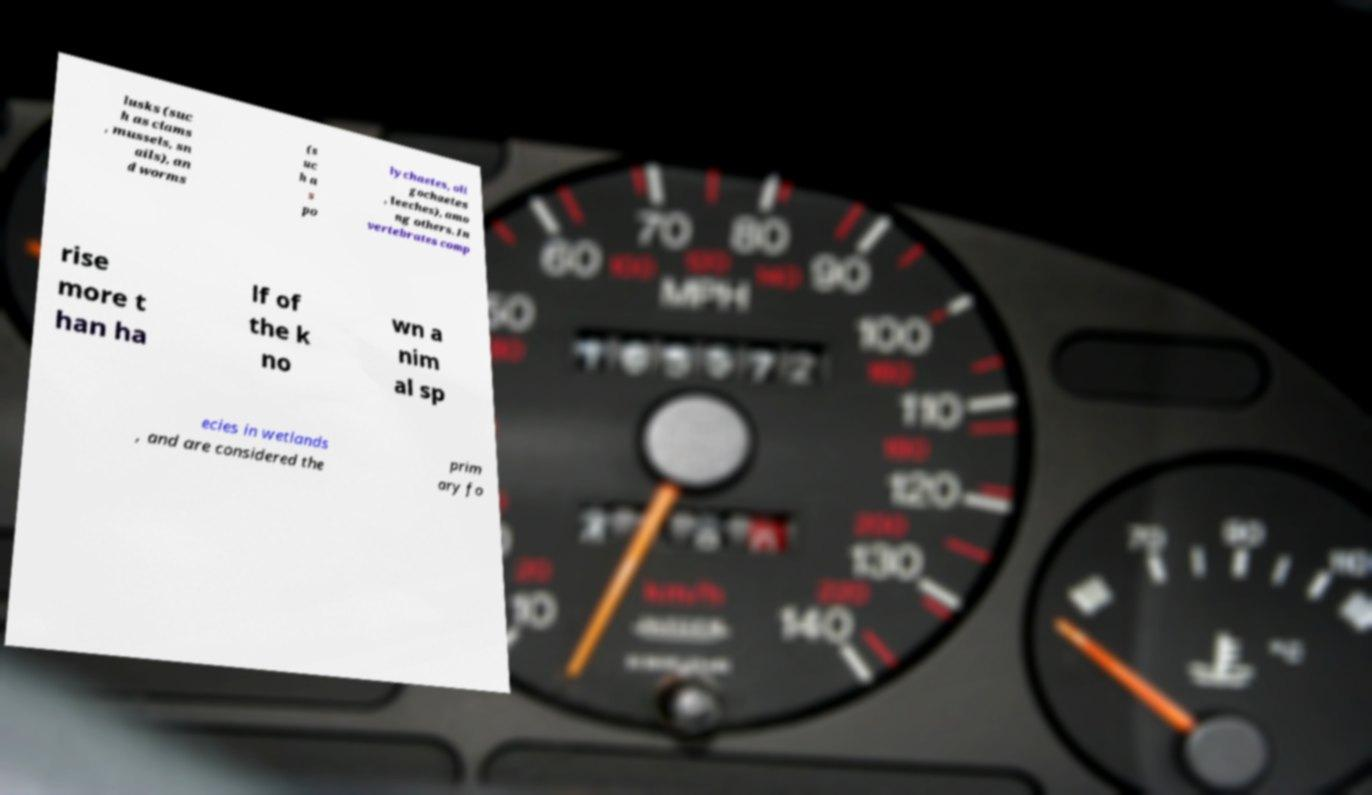What messages or text are displayed in this image? I need them in a readable, typed format. lusks (suc h as clams , mussels, sn ails), an d worms (s uc h a s po lychaetes, oli gochaetes , leeches), amo ng others. In vertebrates comp rise more t han ha lf of the k no wn a nim al sp ecies in wetlands , and are considered the prim ary fo 